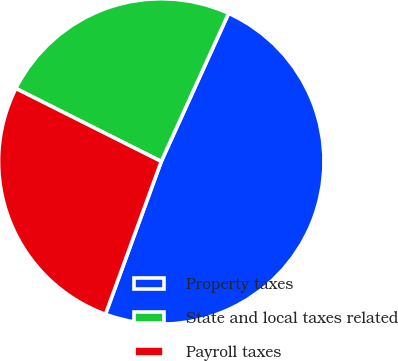<chart> <loc_0><loc_0><loc_500><loc_500><pie_chart><fcel>Property taxes<fcel>State and local taxes related<fcel>Payroll taxes<nl><fcel>48.78%<fcel>24.39%<fcel>26.83%<nl></chart> 